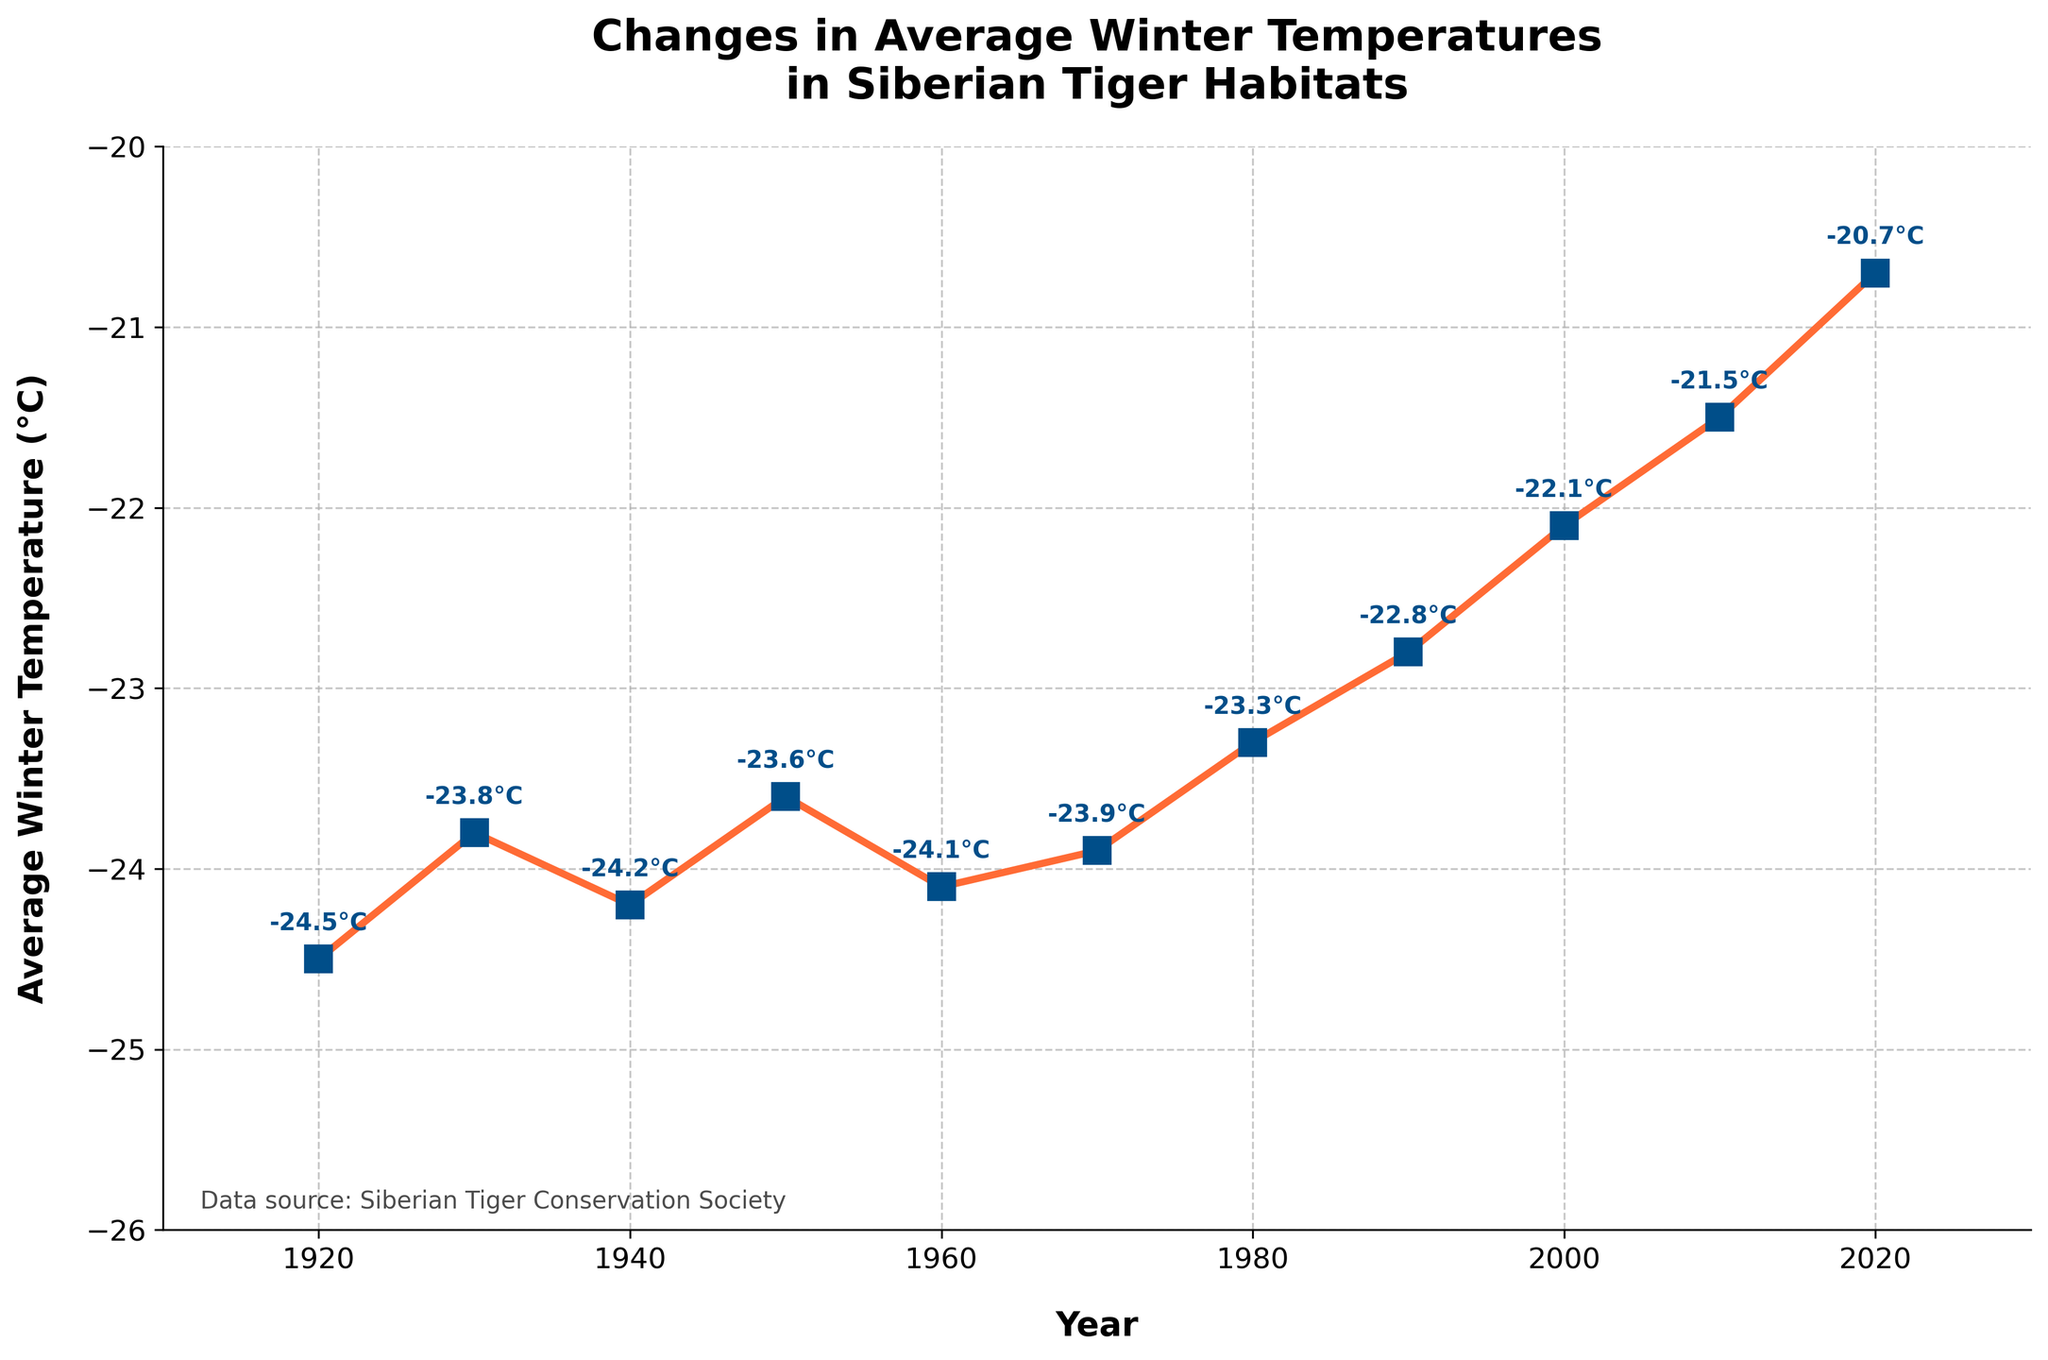What is the overall trend in average winter temperatures in Siberian tiger habitats from 1920 to 2020? The plot shows the temperatures across the years, and the trend line indicates a steady increase in average winter temperatures. Specifically, temperatures rise from -24.5°C in 1920 to -20.7°C in 2020.
Answer: Increasing What was the average winter temperature in Siberian tiger habitats in 1960? Locate the data point for the year 1960 on the x-axis and read the corresponding temperature on the y-axis. The annotated figure confirms that the temperature was -24.1°C.
Answer: -24.1°C How does the temperature change from 1920 to 2020? Provide the difference. Subtract the temperature in 1920 (-24.5°C) from the temperature in 2020 (-20.7°C) to find the change. -20.7 - (-24.5) = 3.8°C.
Answer: 3.8°C Which decade shows the most significant increase in average winter temperature? Examine the temperature changes between each decade on the plot. The most significant increase occurs between 2000 (-22.1°C) and 2010 (-21.5°C) with a rise of 0.6°C.
Answer: 2000 to 2010 Between which two consecutive decades did the average winter temperature remain relatively stable? Look for two consecutive decades where the temperature change is minimal on the chart. The period from 1930 (-23.8°C) to 1940 (-24.2°C) shows a small change of -0.4°C.
Answer: 1930 to 1940 What was the temperature difference between 1950 and 1980? Calculate the difference between temperatures in 1950 (-23.6°C) and 1980 (-23.3°C). -23.3 - (-23.6) = 0.3°C.
Answer: 0.3°C Which year recorded the highest average winter temperature? Identify the highest point on the line graph. The year 2020 shows the highest average winter temperature at -20.7°C.
Answer: 2020 How do temperatures in the 1940s compare to those in the 1980s? Compare the temperature values of the 1940s (-24.2°C) and the 1980s (-23.3°C). 1980s temperatures are higher by 0.9°C.
Answer: 1980s are higher What was the average winter temperature in the year 2000? Find the data point for the year 2000 on the x-axis and read the corresponding temperature on the y-axis. It is -22.1°C.
Answer: -22.1°C What is the general color of the markers used in the plot? Observe the color of the markers on the line chart. They appear in a distinct blue color.
Answer: Blue 